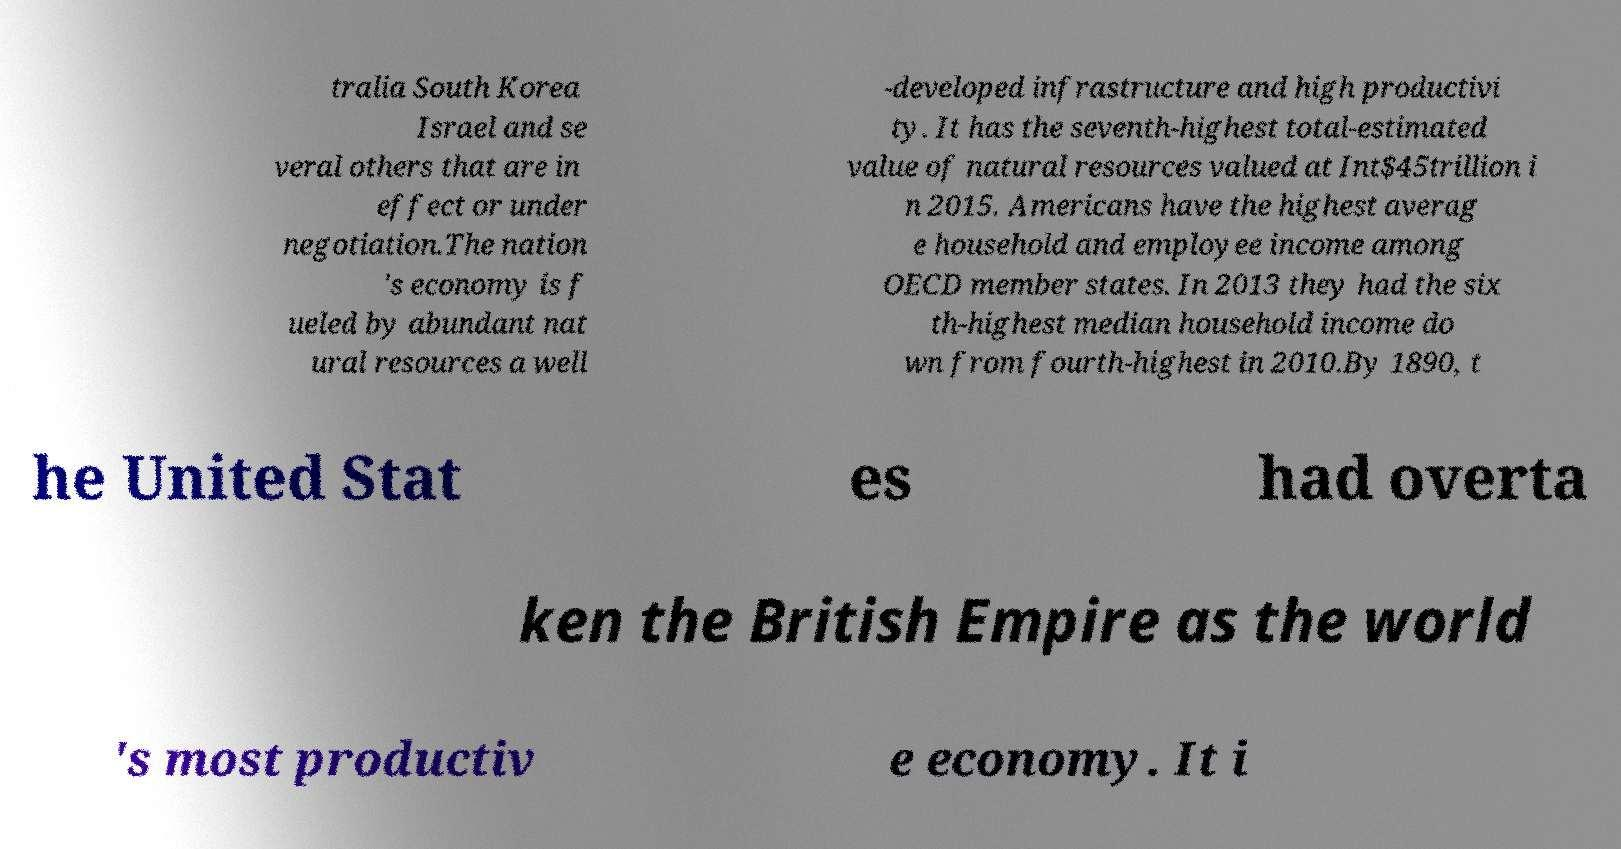Please identify and transcribe the text found in this image. tralia South Korea Israel and se veral others that are in effect or under negotiation.The nation 's economy is f ueled by abundant nat ural resources a well -developed infrastructure and high productivi ty. It has the seventh-highest total-estimated value of natural resources valued at Int$45trillion i n 2015. Americans have the highest averag e household and employee income among OECD member states. In 2013 they had the six th-highest median household income do wn from fourth-highest in 2010.By 1890, t he United Stat es had overta ken the British Empire as the world 's most productiv e economy. It i 